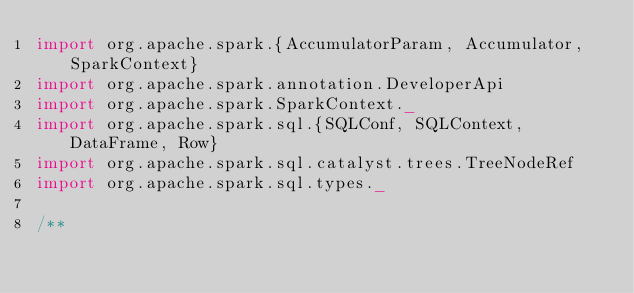<code> <loc_0><loc_0><loc_500><loc_500><_Scala_>import org.apache.spark.{AccumulatorParam, Accumulator, SparkContext}
import org.apache.spark.annotation.DeveloperApi
import org.apache.spark.SparkContext._
import org.apache.spark.sql.{SQLConf, SQLContext, DataFrame, Row}
import org.apache.spark.sql.catalyst.trees.TreeNodeRef
import org.apache.spark.sql.types._

/**</code> 